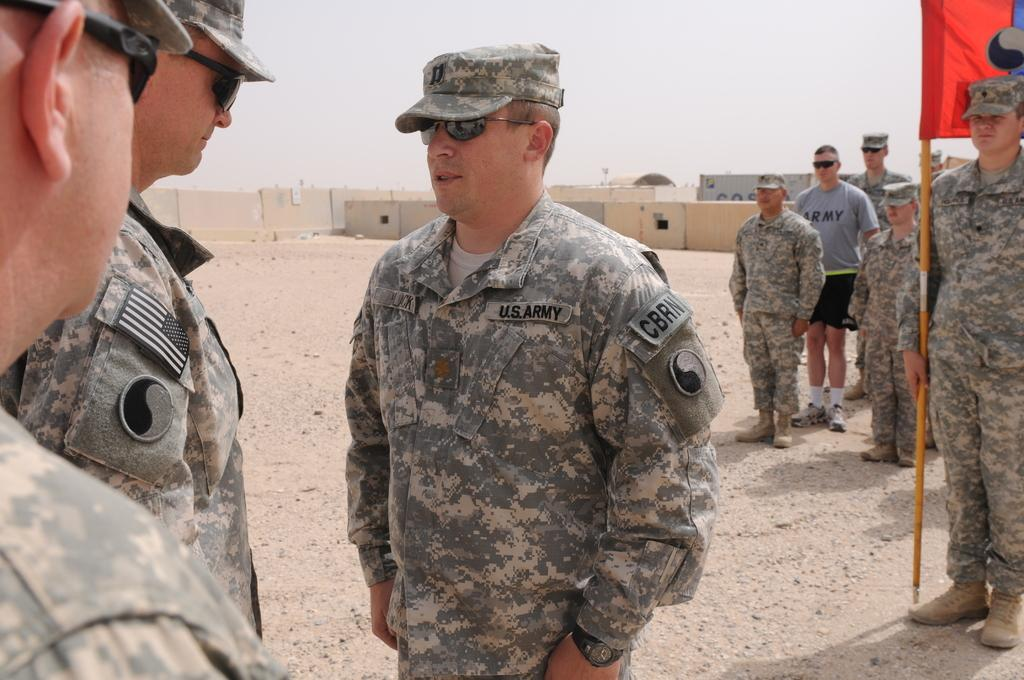What is the main subject of the image? The main subject of the image is a group of people standing. What can be seen hanging on a pole in the image? There is a red color flag hanging on a pole in the image. What type of containers are visible in the background of the image? There are iron containers visible in the background of the image. What type of twig can be seen in the hands of the people in the image? There is no twig visible in the hands of the people in the image. How long did the journey take for the people in the image? The provided facts do not mention any journey or its duration, so we cannot determine the length of the journey from the image. 